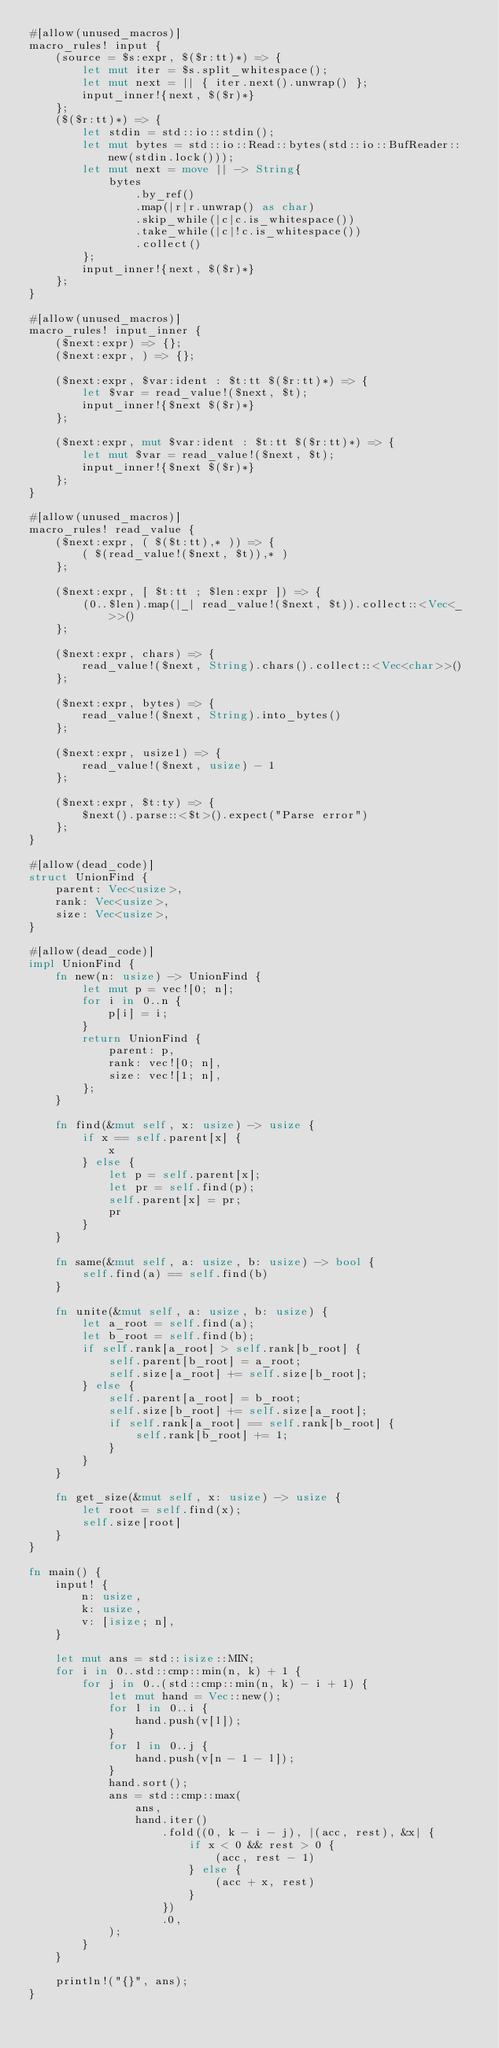<code> <loc_0><loc_0><loc_500><loc_500><_Rust_>#[allow(unused_macros)]
macro_rules! input {
    (source = $s:expr, $($r:tt)*) => {
        let mut iter = $s.split_whitespace();
        let mut next = || { iter.next().unwrap() };
        input_inner!{next, $($r)*}
    };
    ($($r:tt)*) => {
        let stdin = std::io::stdin();
        let mut bytes = std::io::Read::bytes(std::io::BufReader::new(stdin.lock()));
        let mut next = move || -> String{
            bytes
                .by_ref()
                .map(|r|r.unwrap() as char)
                .skip_while(|c|c.is_whitespace())
                .take_while(|c|!c.is_whitespace())
                .collect()
        };
        input_inner!{next, $($r)*}
    };
}

#[allow(unused_macros)]
macro_rules! input_inner {
    ($next:expr) => {};
    ($next:expr, ) => {};

    ($next:expr, $var:ident : $t:tt $($r:tt)*) => {
        let $var = read_value!($next, $t);
        input_inner!{$next $($r)*}
    };

    ($next:expr, mut $var:ident : $t:tt $($r:tt)*) => {
        let mut $var = read_value!($next, $t);
        input_inner!{$next $($r)*}
    };
}

#[allow(unused_macros)]
macro_rules! read_value {
    ($next:expr, ( $($t:tt),* )) => {
        ( $(read_value!($next, $t)),* )
    };

    ($next:expr, [ $t:tt ; $len:expr ]) => {
        (0..$len).map(|_| read_value!($next, $t)).collect::<Vec<_>>()
    };

    ($next:expr, chars) => {
        read_value!($next, String).chars().collect::<Vec<char>>()
    };

    ($next:expr, bytes) => {
        read_value!($next, String).into_bytes()
    };

    ($next:expr, usize1) => {
        read_value!($next, usize) - 1
    };

    ($next:expr, $t:ty) => {
        $next().parse::<$t>().expect("Parse error")
    };
}

#[allow(dead_code)]
struct UnionFind {
    parent: Vec<usize>,
    rank: Vec<usize>,
    size: Vec<usize>,
}

#[allow(dead_code)]
impl UnionFind {
    fn new(n: usize) -> UnionFind {
        let mut p = vec![0; n];
        for i in 0..n {
            p[i] = i;
        }
        return UnionFind {
            parent: p,
            rank: vec![0; n],
            size: vec![1; n],
        };
    }

    fn find(&mut self, x: usize) -> usize {
        if x == self.parent[x] {
            x
        } else {
            let p = self.parent[x];
            let pr = self.find(p);
            self.parent[x] = pr;
            pr
        }
    }

    fn same(&mut self, a: usize, b: usize) -> bool {
        self.find(a) == self.find(b)
    }

    fn unite(&mut self, a: usize, b: usize) {
        let a_root = self.find(a);
        let b_root = self.find(b);
        if self.rank[a_root] > self.rank[b_root] {
            self.parent[b_root] = a_root;
            self.size[a_root] += self.size[b_root];
        } else {
            self.parent[a_root] = b_root;
            self.size[b_root] += self.size[a_root];
            if self.rank[a_root] == self.rank[b_root] {
                self.rank[b_root] += 1;
            }
        }
    }

    fn get_size(&mut self, x: usize) -> usize {
        let root = self.find(x);
        self.size[root]
    }
}

fn main() {
    input! {
        n: usize,
        k: usize,
        v: [isize; n],
    }

    let mut ans = std::isize::MIN;
    for i in 0..std::cmp::min(n, k) + 1 {
        for j in 0..(std::cmp::min(n, k) - i + 1) {
            let mut hand = Vec::new();
            for l in 0..i {
                hand.push(v[l]);
            }
            for l in 0..j {
                hand.push(v[n - 1 - l]);
            }
            hand.sort();
            ans = std::cmp::max(
                ans,
                hand.iter()
                    .fold((0, k - i - j), |(acc, rest), &x| {
                        if x < 0 && rest > 0 {
                            (acc, rest - 1)
                        } else {
                            (acc + x, rest)
                        }
                    })
                    .0,
            );
        }
    }

    println!("{}", ans);
}
</code> 